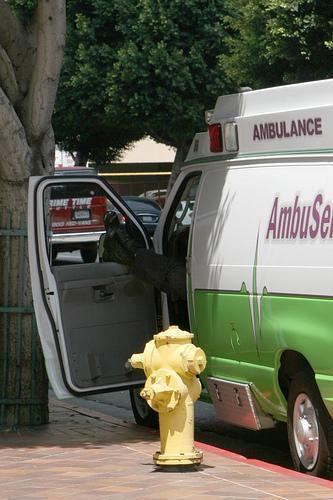Is the statement "The fire hydrant is next to the truck." accurate regarding the image?
Answer yes or no. Yes. 